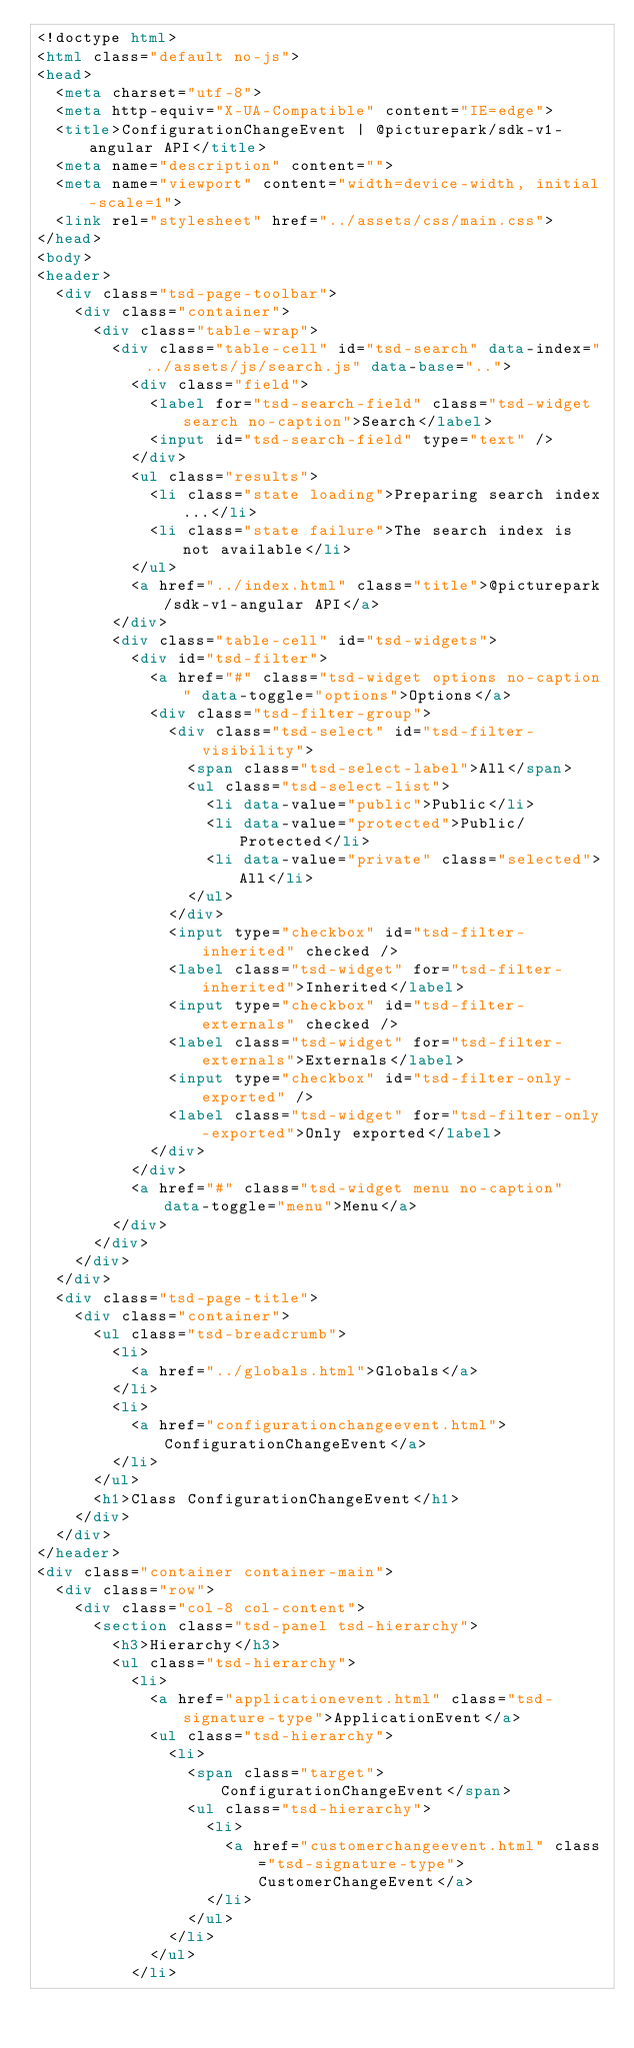<code> <loc_0><loc_0><loc_500><loc_500><_HTML_><!doctype html>
<html class="default no-js">
<head>
	<meta charset="utf-8">
	<meta http-equiv="X-UA-Compatible" content="IE=edge">
	<title>ConfigurationChangeEvent | @picturepark/sdk-v1-angular API</title>
	<meta name="description" content="">
	<meta name="viewport" content="width=device-width, initial-scale=1">
	<link rel="stylesheet" href="../assets/css/main.css">
</head>
<body>
<header>
	<div class="tsd-page-toolbar">
		<div class="container">
			<div class="table-wrap">
				<div class="table-cell" id="tsd-search" data-index="../assets/js/search.js" data-base="..">
					<div class="field">
						<label for="tsd-search-field" class="tsd-widget search no-caption">Search</label>
						<input id="tsd-search-field" type="text" />
					</div>
					<ul class="results">
						<li class="state loading">Preparing search index...</li>
						<li class="state failure">The search index is not available</li>
					</ul>
					<a href="../index.html" class="title">@picturepark/sdk-v1-angular API</a>
				</div>
				<div class="table-cell" id="tsd-widgets">
					<div id="tsd-filter">
						<a href="#" class="tsd-widget options no-caption" data-toggle="options">Options</a>
						<div class="tsd-filter-group">
							<div class="tsd-select" id="tsd-filter-visibility">
								<span class="tsd-select-label">All</span>
								<ul class="tsd-select-list">
									<li data-value="public">Public</li>
									<li data-value="protected">Public/Protected</li>
									<li data-value="private" class="selected">All</li>
								</ul>
							</div>
							<input type="checkbox" id="tsd-filter-inherited" checked />
							<label class="tsd-widget" for="tsd-filter-inherited">Inherited</label>
							<input type="checkbox" id="tsd-filter-externals" checked />
							<label class="tsd-widget" for="tsd-filter-externals">Externals</label>
							<input type="checkbox" id="tsd-filter-only-exported" />
							<label class="tsd-widget" for="tsd-filter-only-exported">Only exported</label>
						</div>
					</div>
					<a href="#" class="tsd-widget menu no-caption" data-toggle="menu">Menu</a>
				</div>
			</div>
		</div>
	</div>
	<div class="tsd-page-title">
		<div class="container">
			<ul class="tsd-breadcrumb">
				<li>
					<a href="../globals.html">Globals</a>
				</li>
				<li>
					<a href="configurationchangeevent.html">ConfigurationChangeEvent</a>
				</li>
			</ul>
			<h1>Class ConfigurationChangeEvent</h1>
		</div>
	</div>
</header>
<div class="container container-main">
	<div class="row">
		<div class="col-8 col-content">
			<section class="tsd-panel tsd-hierarchy">
				<h3>Hierarchy</h3>
				<ul class="tsd-hierarchy">
					<li>
						<a href="applicationevent.html" class="tsd-signature-type">ApplicationEvent</a>
						<ul class="tsd-hierarchy">
							<li>
								<span class="target">ConfigurationChangeEvent</span>
								<ul class="tsd-hierarchy">
									<li>
										<a href="customerchangeevent.html" class="tsd-signature-type">CustomerChangeEvent</a>
									</li>
								</ul>
							</li>
						</ul>
					</li></code> 